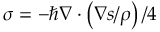<formula> <loc_0><loc_0><loc_500><loc_500>\sigma = - \hbar { \nabla } \cdot \left ( \nabla s / \rho \right ) / 4</formula> 